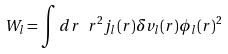Convert formula to latex. <formula><loc_0><loc_0><loc_500><loc_500>W _ { l } = \int d r \ r ^ { 2 } j _ { l } ( r ) \delta v _ { l } ( r ) \phi _ { l } ( r ) ^ { 2 }</formula> 